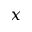<formula> <loc_0><loc_0><loc_500><loc_500>x</formula> 